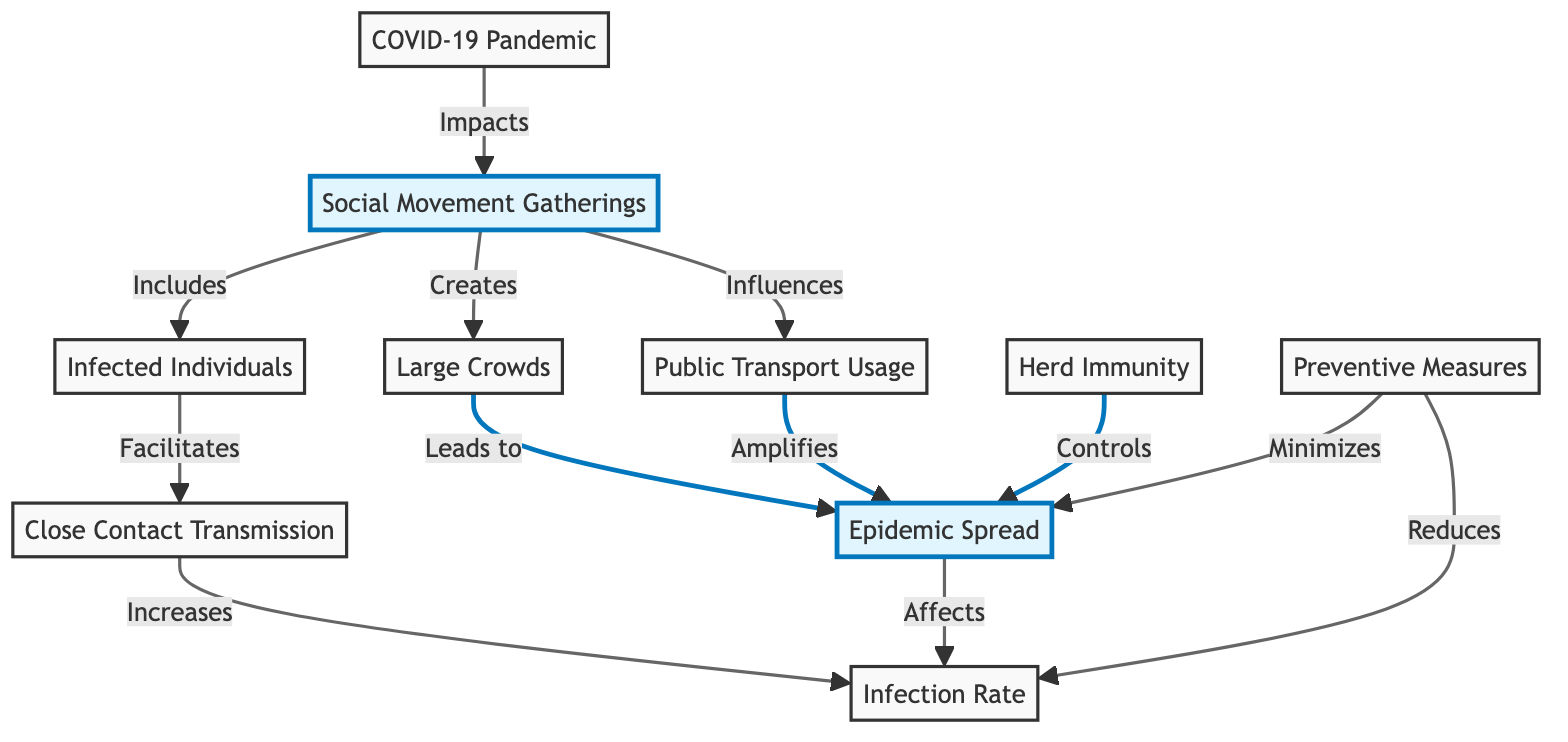What node is highlighted in the diagram? The diagram highlights the nodes "Social Movement Gatherings" and "Epidemic Spread." However, the question specifically asks for one of the highlighted nodes which is "Social Movement Gatherings."
Answer: Social Movement Gatherings How many connections does the node "Epidemic Spread" have? The node "Epidemic Spread" connects to three other nodes: "Large Crowds," "Infection Rate," and "Preventive Measures." Thus, it has three connections.
Answer: 3 Which node directly influences public transport? The node "Social Movement Gatherings" directly influences "Public Transport Usage" as indicated by the arrow from "Social Movement Gatherings" to "Public Transport Usage."
Answer: Social Movement Gatherings What effect do preventive measures have on epidemic spread? The diagram shows that "Preventive Measures" minimizes "Epidemic Spread," indicating a direct reduction effect.
Answer: Minimizes What is the relationship between "Infected Individuals" and "Close Contact Transmission"? "Infected Individuals" facilitates "Close Contact Transmission," meaning that the presence of infected individuals leads to more close contacts among people.
Answer: Facilitates If large crowds are present, what is likely to occur? The presence of "Large Crowds," as per the diagram, leads to "Epidemic Spread," implying that large gatherings may increase the spread of infectious diseases.
Answer: Leads to How does the COVID-19 pandemic impact social gatherings? According to the diagram, "COVID-19 Pandemic" impacts "Social Movement Gatherings," suggesting that the pandemic affects the way social movements gather and engage.
Answer: Impacts What controls epidemic spread according to the diagram? The diagram shows that "Herd Immunity" controls "Epidemic Spread," indicating that a certain level of immunity in the population can prevent the spread of disease.
Answer: Herd Immunity 